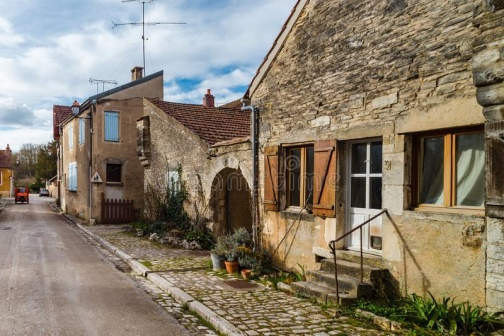What's happening in the scene? The image captures a serene scene from a small village. A narrow, cobblestone street runs through the center of the frame, flanked by quaint stone houses on the right. Each house is topped with an orange roof, adding a warm hue to the overall picture.

The house on the far right stands out with its small garden, adorned with potted plants and enclosed by a wooden gate. The house in the middle is characterized by a white door and a window with green shutters, while the house on the left features a blue door and a window with white shutters.

In the background, power lines stretch across the sky, connecting the houses, and a solitary street lamp stands guard, ready to light up the street as dusk falls. The image exudes a sense of tranquility and timelessness, as if capturing a moment frozen in time in this charming village. 